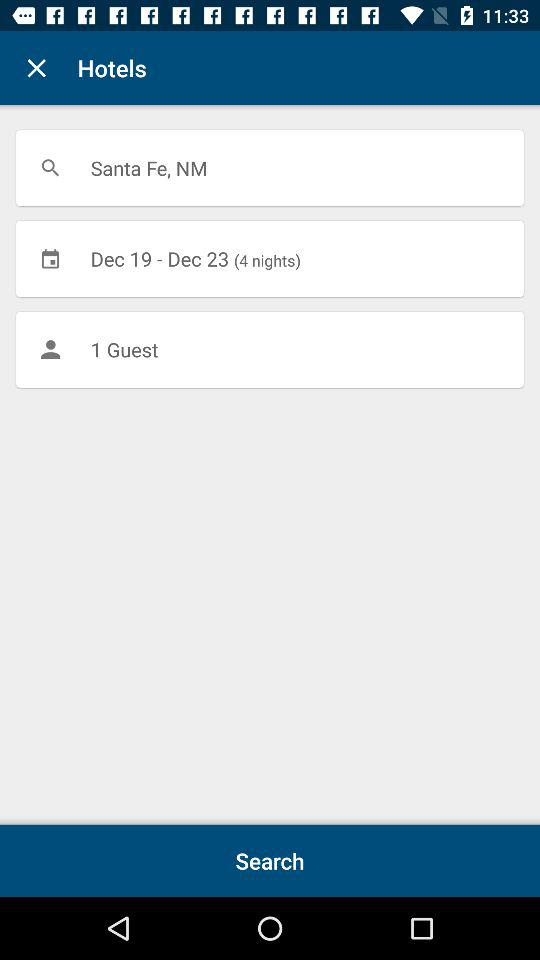What is the number of guests? There is 1 guest. 